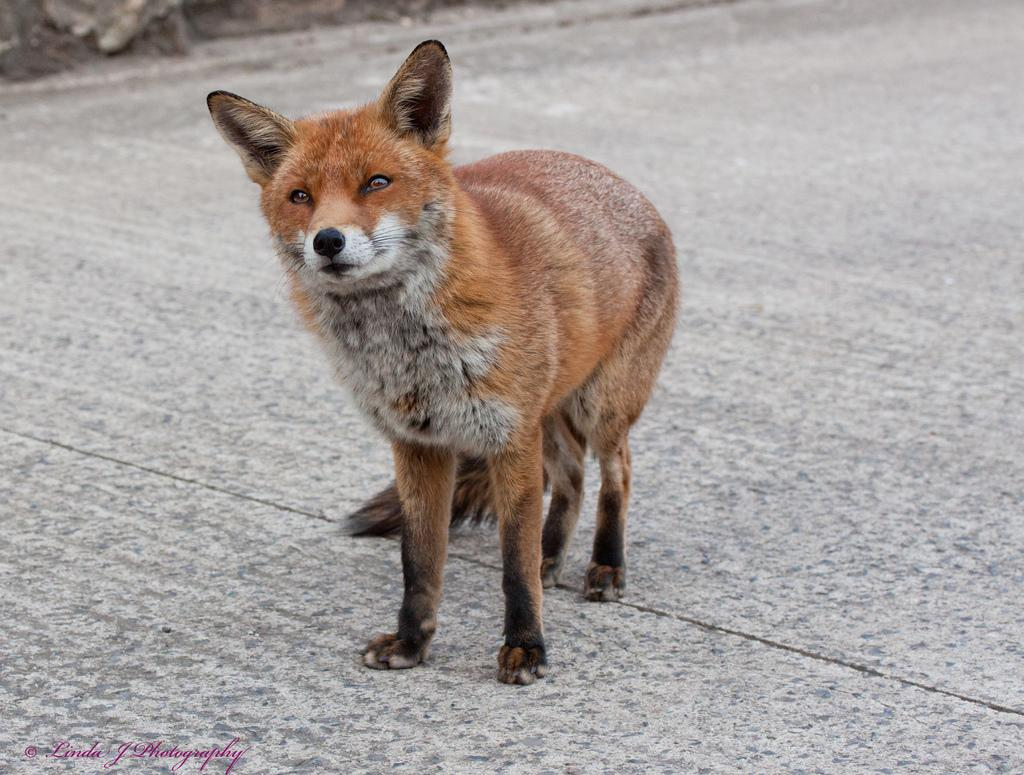What animal can be seen in the image? There is a dog in the image. Where is the dog located? The dog is standing on the road. When was the image taken? The image was taken during the day. What type of sweater is the dog wearing in the image? There is no sweater present in the image; the dog is not wearing any clothing. 